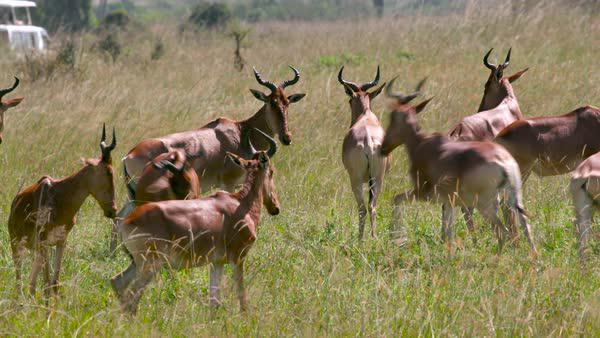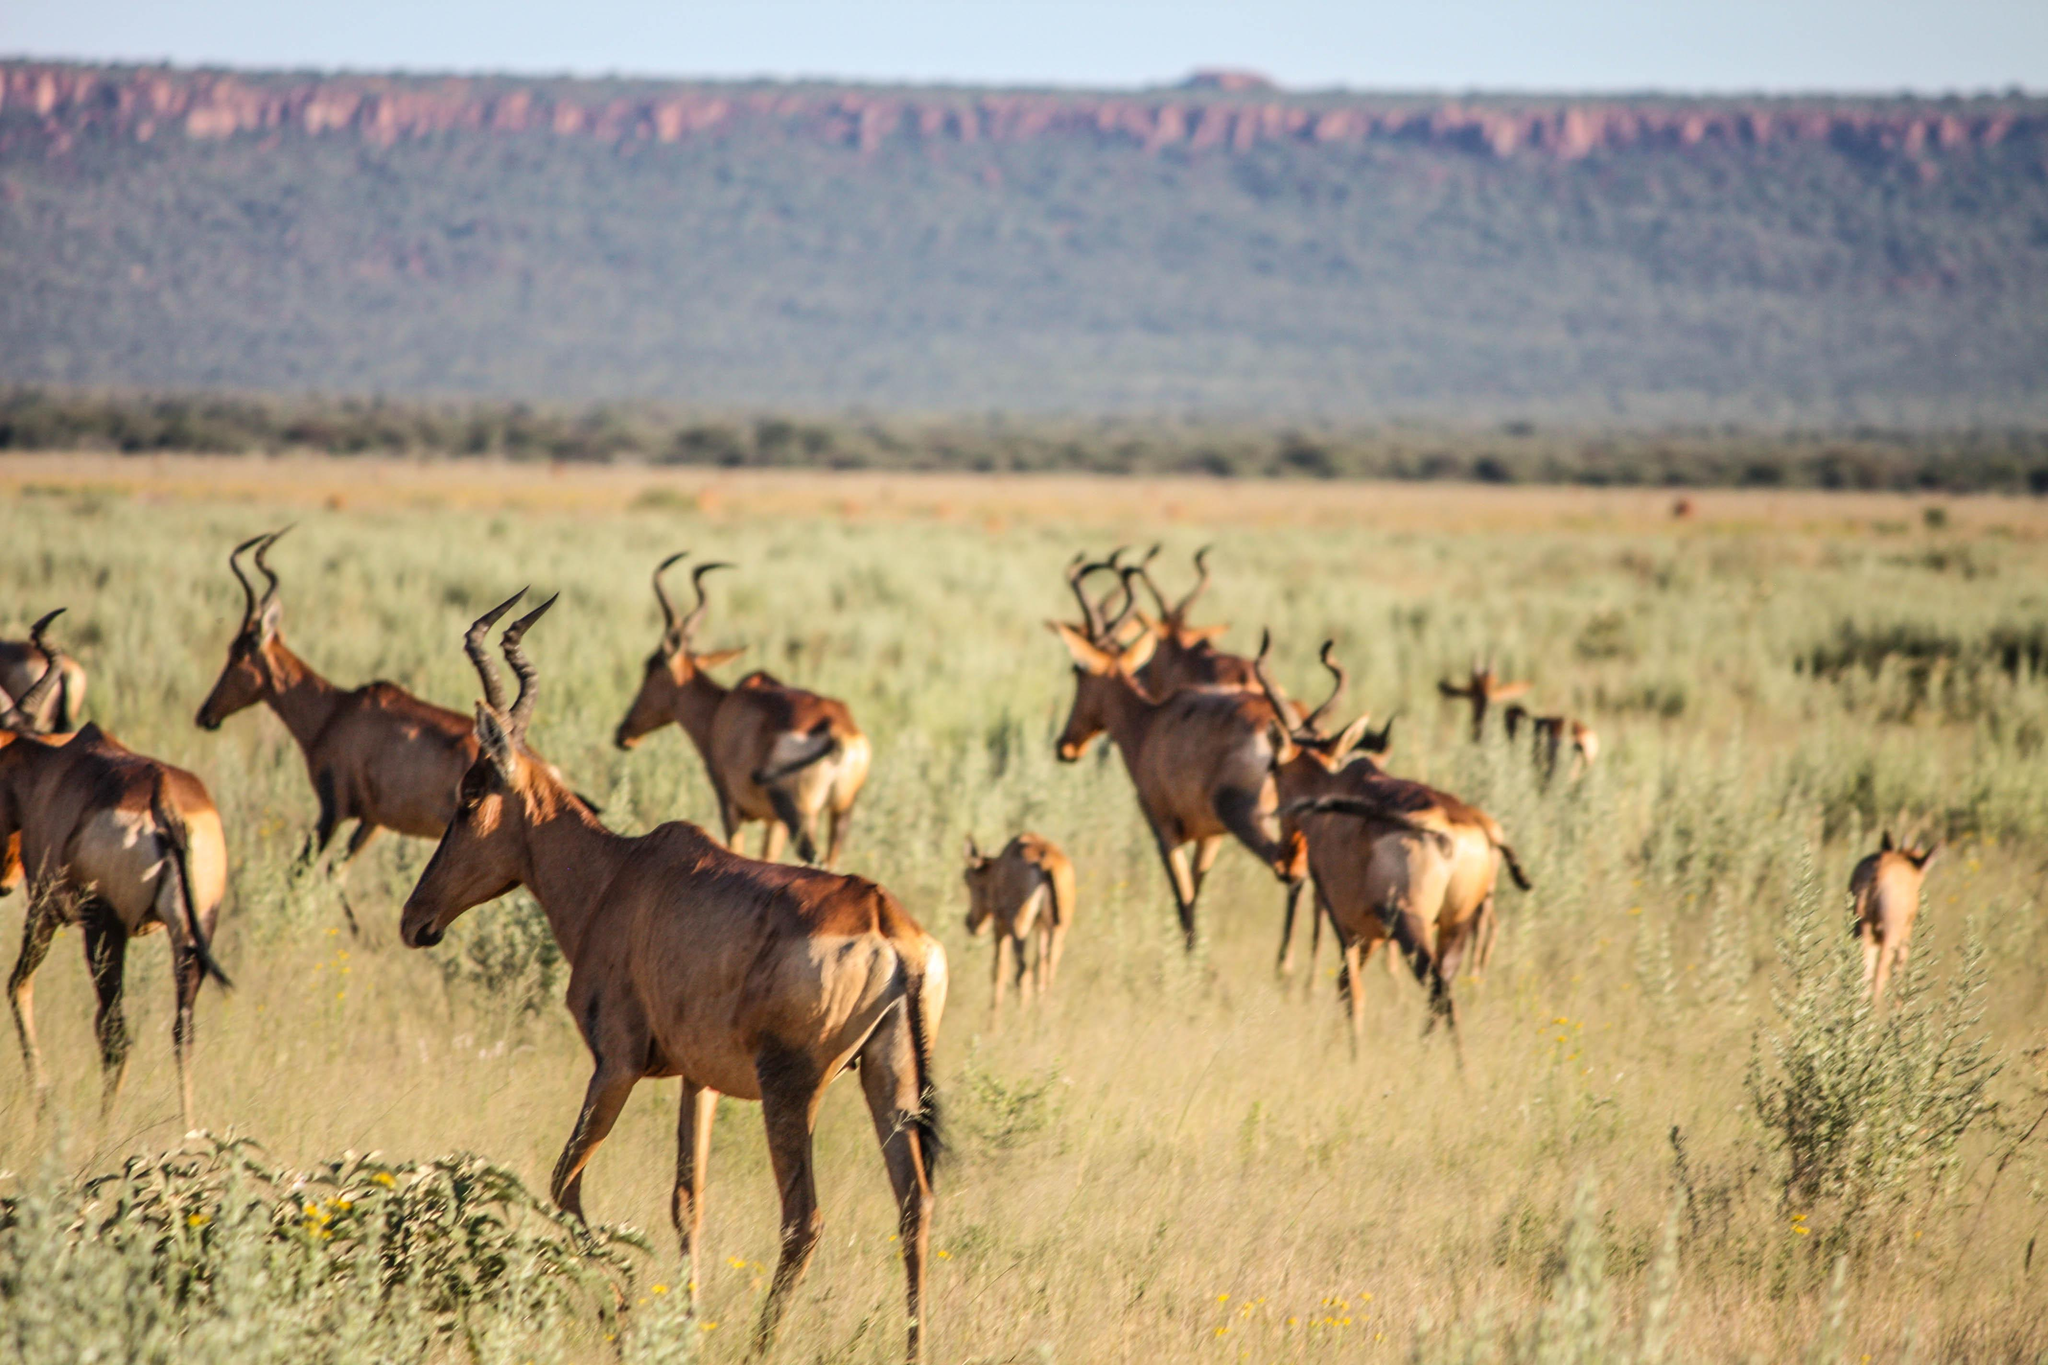The first image is the image on the left, the second image is the image on the right. Analyze the images presented: Is the assertion "The sky can not be seen in the image on the left." valid? Answer yes or no. Yes. 